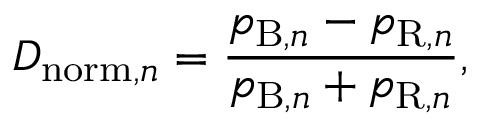Convert formula to latex. <formula><loc_0><loc_0><loc_500><loc_500>D _ { n o r m , n } = \frac { p _ { B , n } - p _ { R , n } } { p _ { B , n } + p _ { R , n } } ,</formula> 